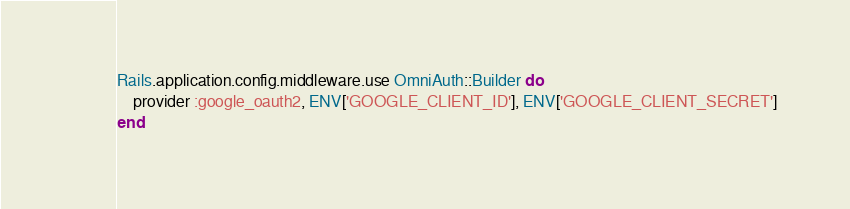<code> <loc_0><loc_0><loc_500><loc_500><_Ruby_>
Rails.application.config.middleware.use OmniAuth::Builder do
    provider :google_oauth2, ENV['GOOGLE_CLIENT_ID'], ENV['GOOGLE_CLIENT_SECRET']
end

</code> 